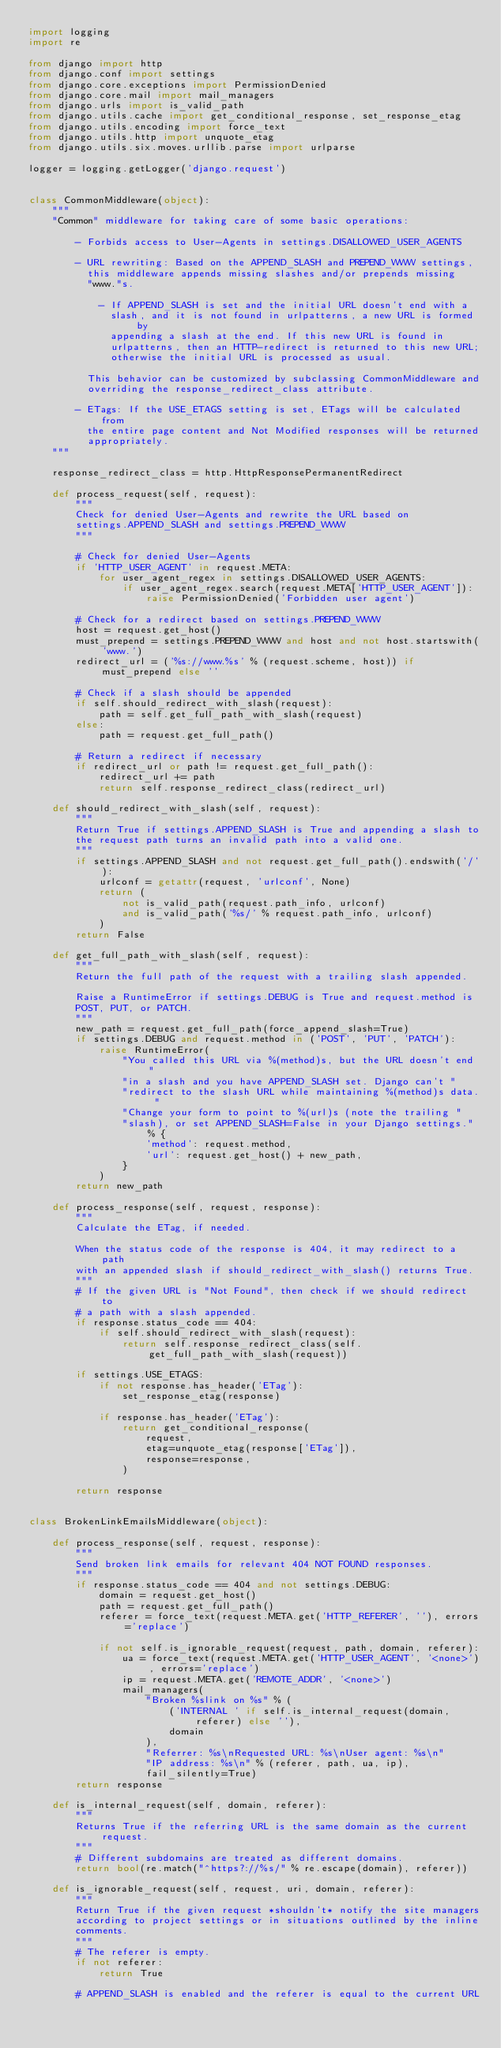Convert code to text. <code><loc_0><loc_0><loc_500><loc_500><_Python_>import logging
import re

from django import http
from django.conf import settings
from django.core.exceptions import PermissionDenied
from django.core.mail import mail_managers
from django.urls import is_valid_path
from django.utils.cache import get_conditional_response, set_response_etag
from django.utils.encoding import force_text
from django.utils.http import unquote_etag
from django.utils.six.moves.urllib.parse import urlparse

logger = logging.getLogger('django.request')


class CommonMiddleware(object):
    """
    "Common" middleware for taking care of some basic operations:

        - Forbids access to User-Agents in settings.DISALLOWED_USER_AGENTS

        - URL rewriting: Based on the APPEND_SLASH and PREPEND_WWW settings,
          this middleware appends missing slashes and/or prepends missing
          "www."s.

            - If APPEND_SLASH is set and the initial URL doesn't end with a
              slash, and it is not found in urlpatterns, a new URL is formed by
              appending a slash at the end. If this new URL is found in
              urlpatterns, then an HTTP-redirect is returned to this new URL;
              otherwise the initial URL is processed as usual.

          This behavior can be customized by subclassing CommonMiddleware and
          overriding the response_redirect_class attribute.

        - ETags: If the USE_ETAGS setting is set, ETags will be calculated from
          the entire page content and Not Modified responses will be returned
          appropriately.
    """

    response_redirect_class = http.HttpResponsePermanentRedirect

    def process_request(self, request):
        """
        Check for denied User-Agents and rewrite the URL based on
        settings.APPEND_SLASH and settings.PREPEND_WWW
        """

        # Check for denied User-Agents
        if 'HTTP_USER_AGENT' in request.META:
            for user_agent_regex in settings.DISALLOWED_USER_AGENTS:
                if user_agent_regex.search(request.META['HTTP_USER_AGENT']):
                    raise PermissionDenied('Forbidden user agent')

        # Check for a redirect based on settings.PREPEND_WWW
        host = request.get_host()
        must_prepend = settings.PREPEND_WWW and host and not host.startswith('www.')
        redirect_url = ('%s://www.%s' % (request.scheme, host)) if must_prepend else ''

        # Check if a slash should be appended
        if self.should_redirect_with_slash(request):
            path = self.get_full_path_with_slash(request)
        else:
            path = request.get_full_path()

        # Return a redirect if necessary
        if redirect_url or path != request.get_full_path():
            redirect_url += path
            return self.response_redirect_class(redirect_url)

    def should_redirect_with_slash(self, request):
        """
        Return True if settings.APPEND_SLASH is True and appending a slash to
        the request path turns an invalid path into a valid one.
        """
        if settings.APPEND_SLASH and not request.get_full_path().endswith('/'):
            urlconf = getattr(request, 'urlconf', None)
            return (
                not is_valid_path(request.path_info, urlconf)
                and is_valid_path('%s/' % request.path_info, urlconf)
            )
        return False

    def get_full_path_with_slash(self, request):
        """
        Return the full path of the request with a trailing slash appended.

        Raise a RuntimeError if settings.DEBUG is True and request.method is
        POST, PUT, or PATCH.
        """
        new_path = request.get_full_path(force_append_slash=True)
        if settings.DEBUG and request.method in ('POST', 'PUT', 'PATCH'):
            raise RuntimeError(
                "You called this URL via %(method)s, but the URL doesn't end "
                "in a slash and you have APPEND_SLASH set. Django can't "
                "redirect to the slash URL while maintaining %(method)s data. "
                "Change your form to point to %(url)s (note the trailing "
                "slash), or set APPEND_SLASH=False in your Django settings." % {
                    'method': request.method,
                    'url': request.get_host() + new_path,
                }
            )
        return new_path

    def process_response(self, request, response):
        """
        Calculate the ETag, if needed.

        When the status code of the response is 404, it may redirect to a path
        with an appended slash if should_redirect_with_slash() returns True.
        """
        # If the given URL is "Not Found", then check if we should redirect to
        # a path with a slash appended.
        if response.status_code == 404:
            if self.should_redirect_with_slash(request):
                return self.response_redirect_class(self.get_full_path_with_slash(request))

        if settings.USE_ETAGS:
            if not response.has_header('ETag'):
                set_response_etag(response)

            if response.has_header('ETag'):
                return get_conditional_response(
                    request,
                    etag=unquote_etag(response['ETag']),
                    response=response,
                )

        return response


class BrokenLinkEmailsMiddleware(object):

    def process_response(self, request, response):
        """
        Send broken link emails for relevant 404 NOT FOUND responses.
        """
        if response.status_code == 404 and not settings.DEBUG:
            domain = request.get_host()
            path = request.get_full_path()
            referer = force_text(request.META.get('HTTP_REFERER', ''), errors='replace')

            if not self.is_ignorable_request(request, path, domain, referer):
                ua = force_text(request.META.get('HTTP_USER_AGENT', '<none>'), errors='replace')
                ip = request.META.get('REMOTE_ADDR', '<none>')
                mail_managers(
                    "Broken %slink on %s" % (
                        ('INTERNAL ' if self.is_internal_request(domain, referer) else ''),
                        domain
                    ),
                    "Referrer: %s\nRequested URL: %s\nUser agent: %s\n"
                    "IP address: %s\n" % (referer, path, ua, ip),
                    fail_silently=True)
        return response

    def is_internal_request(self, domain, referer):
        """
        Returns True if the referring URL is the same domain as the current request.
        """
        # Different subdomains are treated as different domains.
        return bool(re.match("^https?://%s/" % re.escape(domain), referer))

    def is_ignorable_request(self, request, uri, domain, referer):
        """
        Return True if the given request *shouldn't* notify the site managers
        according to project settings or in situations outlined by the inline
        comments.
        """
        # The referer is empty.
        if not referer:
            return True

        # APPEND_SLASH is enabled and the referer is equal to the current URL</code> 